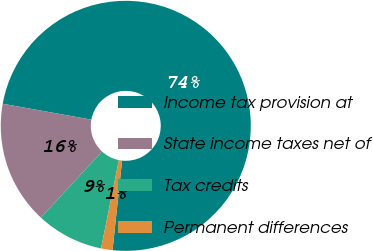Convert chart to OTSL. <chart><loc_0><loc_0><loc_500><loc_500><pie_chart><fcel>Income tax provision at<fcel>State income taxes net of<fcel>Tax credits<fcel>Permanent differences<nl><fcel>73.86%<fcel>15.95%<fcel>8.71%<fcel>1.48%<nl></chart> 